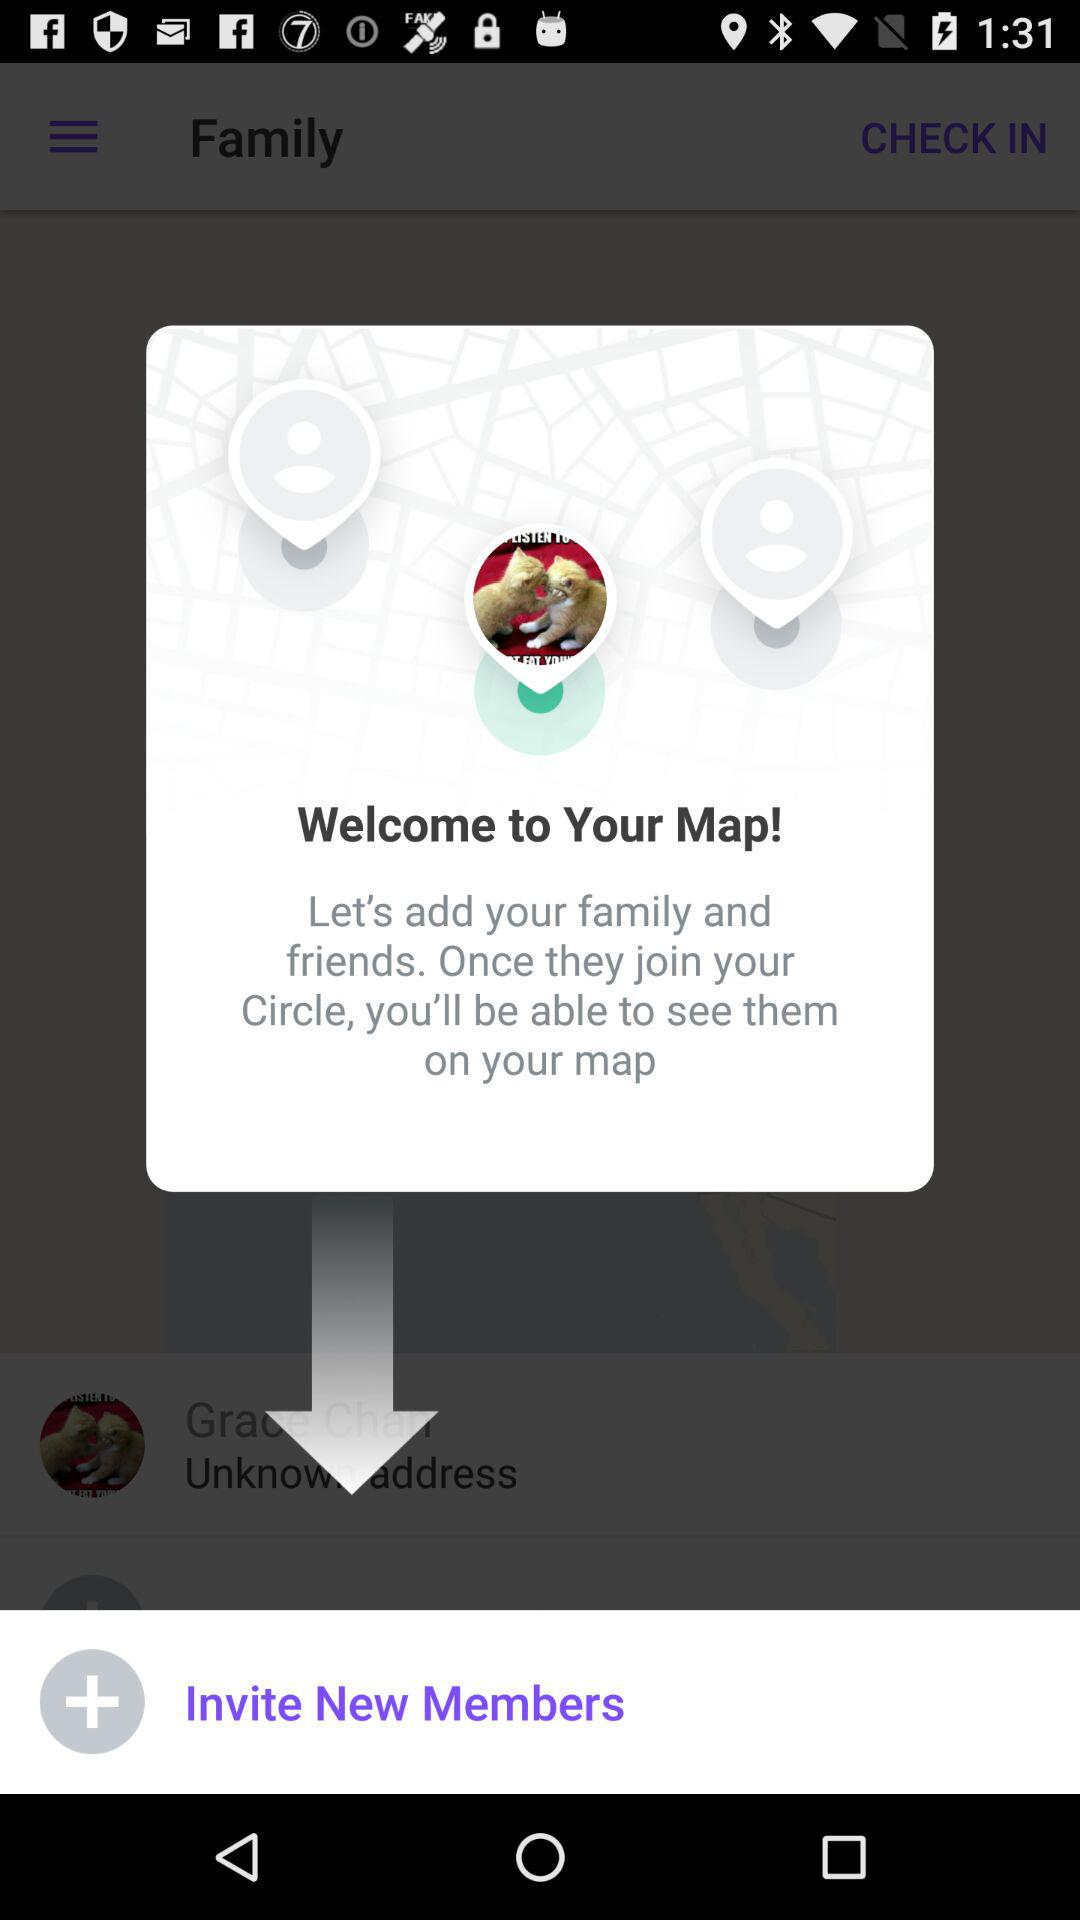What is the app name? The app name is "Your Map". 